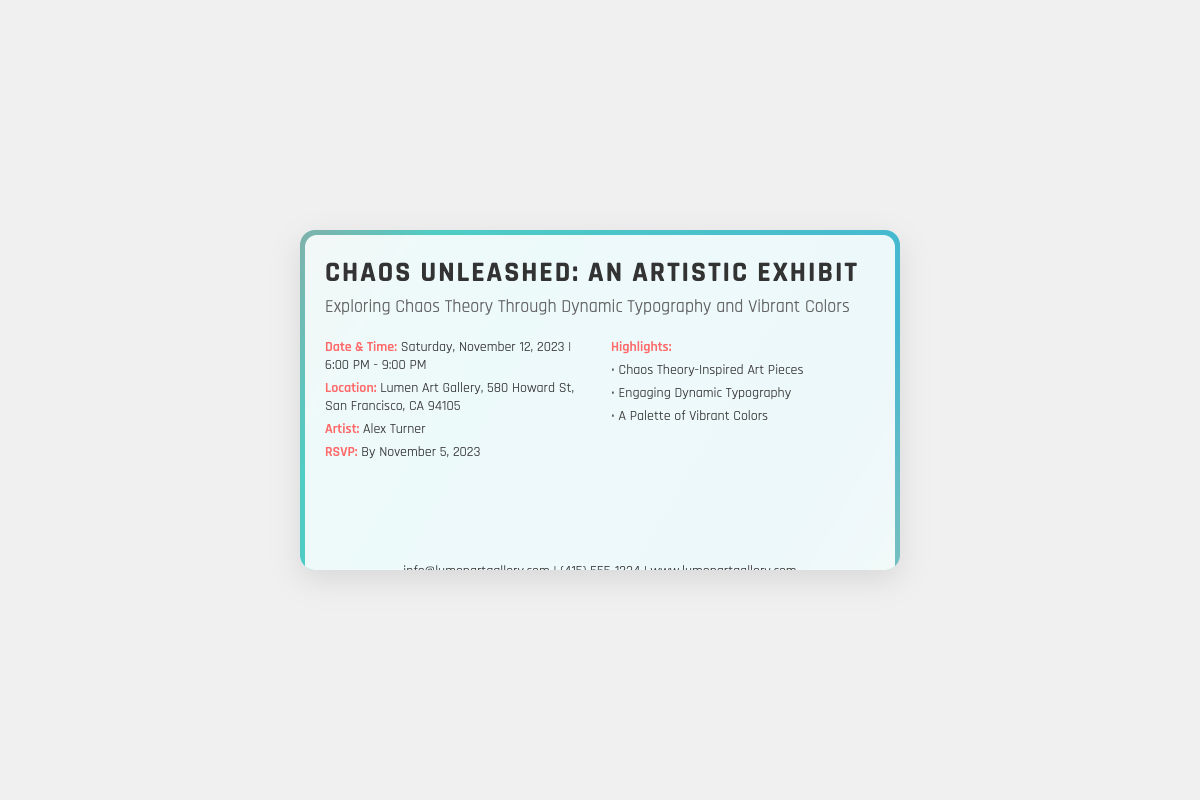What is the name of the exhibit? The name of the exhibit is clearly stated as the title in the document.
Answer: Chaos Unleashed: An Artistic Exhibit Who is the artist featured in the exhibit? The artist's name is specified in the details section of the document.
Answer: Alex Turner What is the location of the exhibit? The location is provided in the details section of the document.
Answer: Lumen Art Gallery, 580 Howard St, San Francisco, CA 94105 What is the RSVP deadline for the exhibit? The RSVP date is highlighted in the details section of the document.
Answer: By November 5, 2023 What type of art pieces will be showcased? The highlights section lists the type of art pieces featured in the exhibit.
Answer: Chaos Theory-Inspired Art Pieces What is expected from the typography in the exhibit? The description in the document explains the typography style being used.
Answer: Engaging Dynamic Typography What is the color theme of the exhibit? The highlight section mentions the colors used throughout the exhibit.
Answer: A Palette of Vibrant Colors 